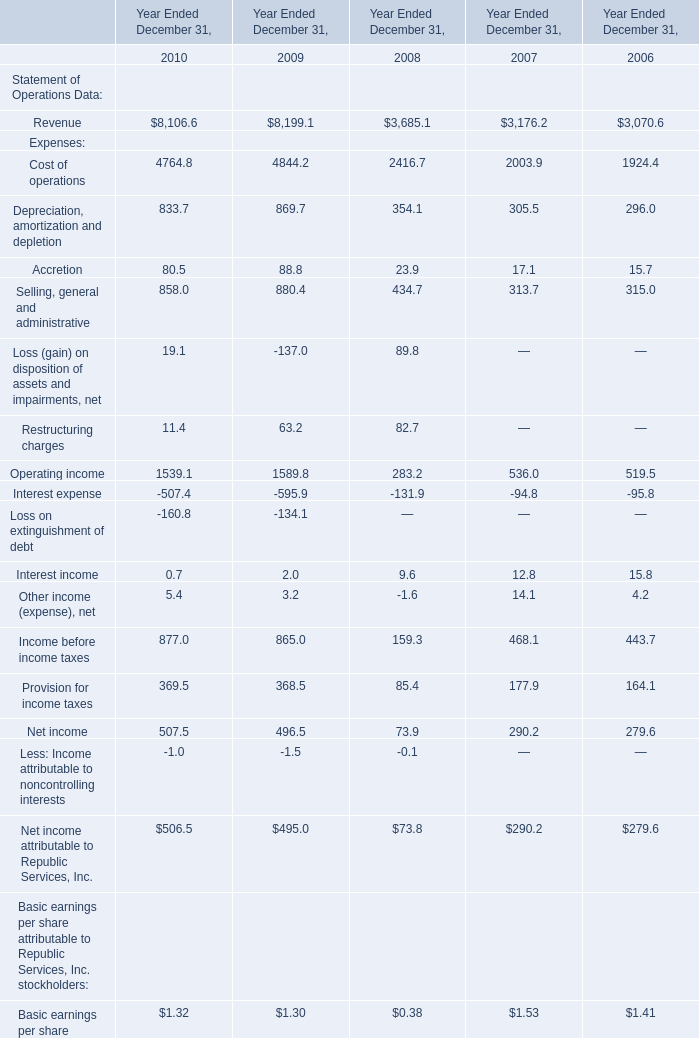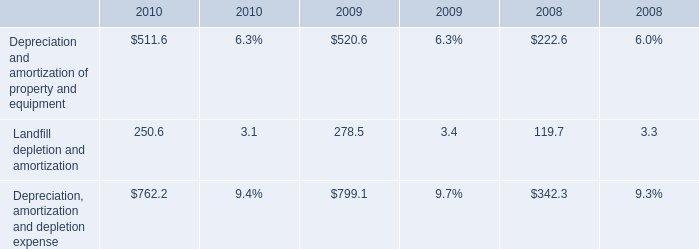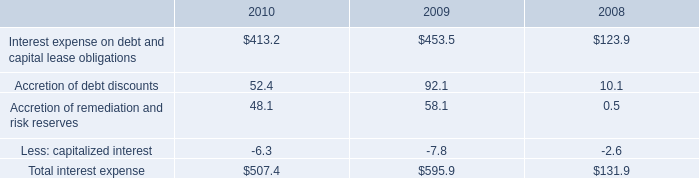What was the sum of Revenue without those Revenue smaller than 4000? 
Computations: (8106.6 + 8199.1)
Answer: 16305.7. 